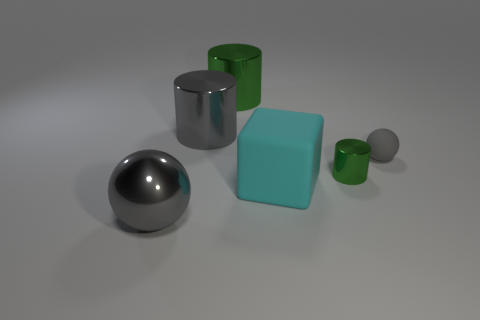Subtract all large shiny cylinders. How many cylinders are left? 1 Add 4 green metallic cylinders. How many objects exist? 10 Subtract all green cylinders. How many cylinders are left? 1 Subtract all cubes. How many objects are left? 5 Add 1 blocks. How many blocks are left? 2 Add 1 gray metallic balls. How many gray metallic balls exist? 2 Subtract 1 gray cylinders. How many objects are left? 5 Subtract 1 spheres. How many spheres are left? 1 Subtract all blue spheres. Subtract all blue cubes. How many spheres are left? 2 Subtract all green cylinders. How many green cubes are left? 0 